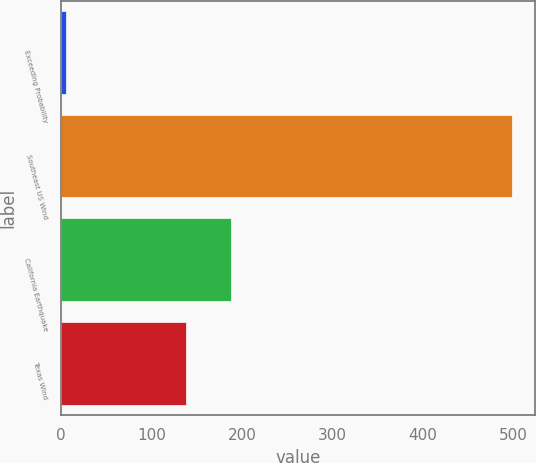<chart> <loc_0><loc_0><loc_500><loc_500><bar_chart><fcel>Exceeding Probability<fcel>Southeast US Wind<fcel>California Earthquake<fcel>Texas Wind<nl><fcel>5<fcel>499<fcel>187.4<fcel>138<nl></chart> 